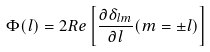Convert formula to latex. <formula><loc_0><loc_0><loc_500><loc_500>\Phi ( l ) = 2 R e \left [ \frac { \partial \delta _ { l m } } { \partial l } ( m = \pm l ) \right ]</formula> 